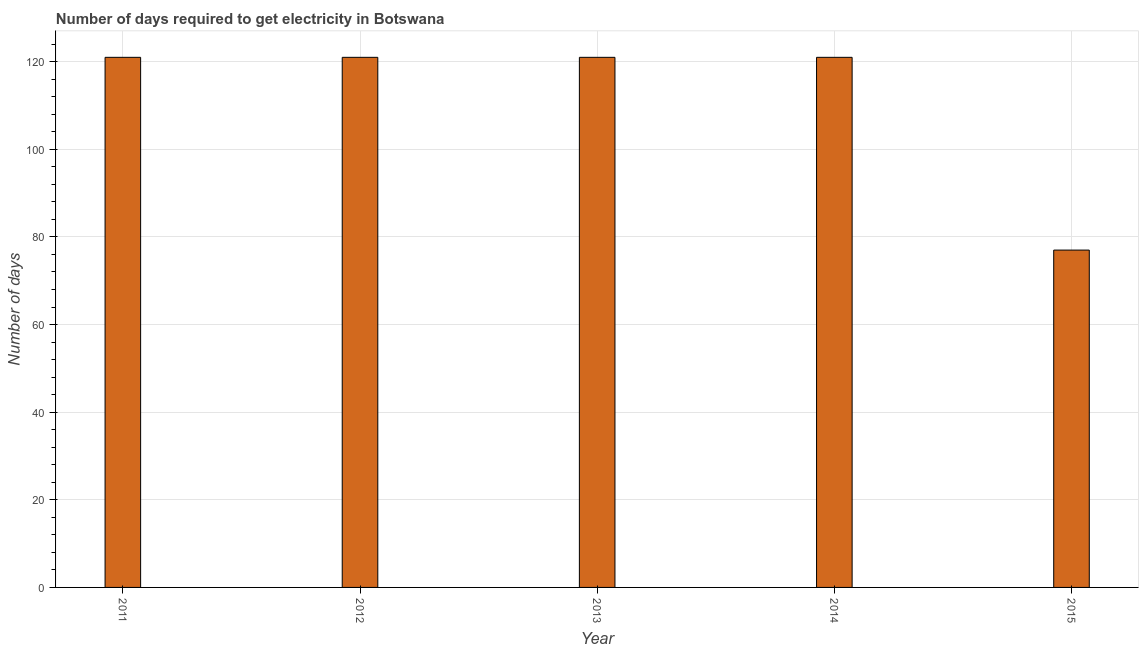Does the graph contain any zero values?
Keep it short and to the point. No. What is the title of the graph?
Provide a succinct answer. Number of days required to get electricity in Botswana. What is the label or title of the X-axis?
Your response must be concise. Year. What is the label or title of the Y-axis?
Ensure brevity in your answer.  Number of days. Across all years, what is the maximum time to get electricity?
Give a very brief answer. 121. Across all years, what is the minimum time to get electricity?
Make the answer very short. 77. In which year was the time to get electricity minimum?
Your answer should be very brief. 2015. What is the sum of the time to get electricity?
Provide a short and direct response. 561. What is the difference between the time to get electricity in 2012 and 2015?
Make the answer very short. 44. What is the average time to get electricity per year?
Your response must be concise. 112. What is the median time to get electricity?
Offer a terse response. 121. In how many years, is the time to get electricity greater than 112 ?
Your answer should be compact. 4. Is the difference between the time to get electricity in 2013 and 2015 greater than the difference between any two years?
Your answer should be compact. Yes. What is the difference between the highest and the second highest time to get electricity?
Provide a short and direct response. 0. How many bars are there?
Offer a very short reply. 5. How many years are there in the graph?
Your answer should be compact. 5. What is the difference between two consecutive major ticks on the Y-axis?
Your answer should be compact. 20. Are the values on the major ticks of Y-axis written in scientific E-notation?
Provide a short and direct response. No. What is the Number of days of 2011?
Your response must be concise. 121. What is the Number of days in 2012?
Your answer should be very brief. 121. What is the Number of days in 2013?
Your answer should be very brief. 121. What is the Number of days of 2014?
Your answer should be very brief. 121. What is the Number of days in 2015?
Your answer should be very brief. 77. What is the difference between the Number of days in 2011 and 2012?
Keep it short and to the point. 0. What is the difference between the Number of days in 2011 and 2014?
Provide a short and direct response. 0. What is the difference between the Number of days in 2012 and 2014?
Provide a succinct answer. 0. What is the difference between the Number of days in 2013 and 2015?
Keep it short and to the point. 44. What is the ratio of the Number of days in 2011 to that in 2015?
Give a very brief answer. 1.57. What is the ratio of the Number of days in 2012 to that in 2013?
Your response must be concise. 1. What is the ratio of the Number of days in 2012 to that in 2014?
Your response must be concise. 1. What is the ratio of the Number of days in 2012 to that in 2015?
Offer a very short reply. 1.57. What is the ratio of the Number of days in 2013 to that in 2014?
Keep it short and to the point. 1. What is the ratio of the Number of days in 2013 to that in 2015?
Offer a terse response. 1.57. What is the ratio of the Number of days in 2014 to that in 2015?
Keep it short and to the point. 1.57. 